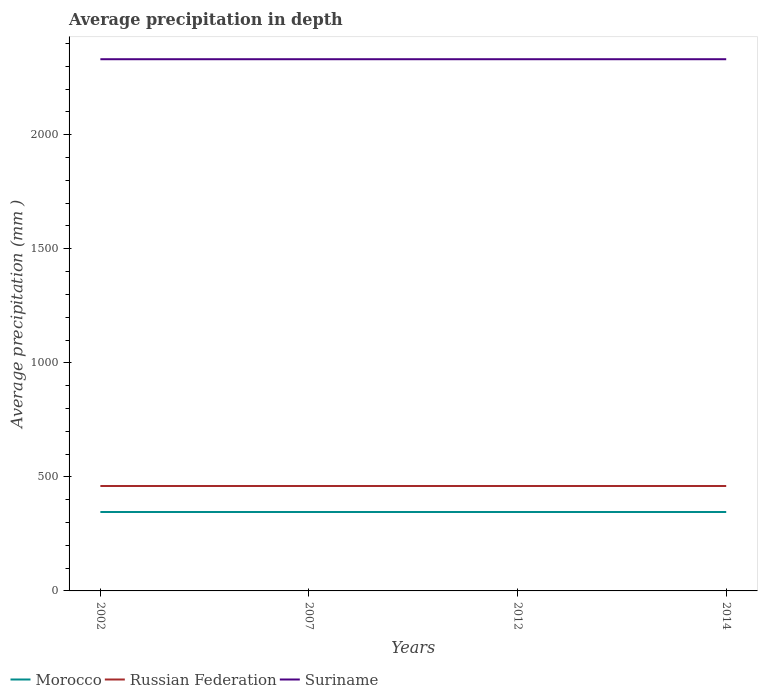How many different coloured lines are there?
Ensure brevity in your answer.  3. Across all years, what is the maximum average precipitation in Russian Federation?
Your response must be concise. 460. In which year was the average precipitation in Russian Federation maximum?
Your response must be concise. 2002. What is the total average precipitation in Russian Federation in the graph?
Make the answer very short. 0. What is the difference between the highest and the lowest average precipitation in Morocco?
Provide a short and direct response. 0. How many years are there in the graph?
Your answer should be compact. 4. Does the graph contain any zero values?
Provide a succinct answer. No. Where does the legend appear in the graph?
Provide a short and direct response. Bottom left. How many legend labels are there?
Your response must be concise. 3. What is the title of the graph?
Your answer should be compact. Average precipitation in depth. What is the label or title of the Y-axis?
Keep it short and to the point. Average precipitation (mm ). What is the Average precipitation (mm ) in Morocco in 2002?
Offer a very short reply. 346. What is the Average precipitation (mm ) of Russian Federation in 2002?
Give a very brief answer. 460. What is the Average precipitation (mm ) in Suriname in 2002?
Provide a succinct answer. 2331. What is the Average precipitation (mm ) in Morocco in 2007?
Keep it short and to the point. 346. What is the Average precipitation (mm ) in Russian Federation in 2007?
Your answer should be very brief. 460. What is the Average precipitation (mm ) in Suriname in 2007?
Make the answer very short. 2331. What is the Average precipitation (mm ) of Morocco in 2012?
Offer a terse response. 346. What is the Average precipitation (mm ) in Russian Federation in 2012?
Your answer should be very brief. 460. What is the Average precipitation (mm ) in Suriname in 2012?
Provide a succinct answer. 2331. What is the Average precipitation (mm ) of Morocco in 2014?
Make the answer very short. 346. What is the Average precipitation (mm ) in Russian Federation in 2014?
Offer a terse response. 460. What is the Average precipitation (mm ) in Suriname in 2014?
Offer a very short reply. 2331. Across all years, what is the maximum Average precipitation (mm ) of Morocco?
Ensure brevity in your answer.  346. Across all years, what is the maximum Average precipitation (mm ) of Russian Federation?
Ensure brevity in your answer.  460. Across all years, what is the maximum Average precipitation (mm ) of Suriname?
Ensure brevity in your answer.  2331. Across all years, what is the minimum Average precipitation (mm ) in Morocco?
Offer a very short reply. 346. Across all years, what is the minimum Average precipitation (mm ) of Russian Federation?
Your response must be concise. 460. Across all years, what is the minimum Average precipitation (mm ) in Suriname?
Make the answer very short. 2331. What is the total Average precipitation (mm ) of Morocco in the graph?
Provide a short and direct response. 1384. What is the total Average precipitation (mm ) of Russian Federation in the graph?
Your response must be concise. 1840. What is the total Average precipitation (mm ) of Suriname in the graph?
Your answer should be compact. 9324. What is the difference between the Average precipitation (mm ) in Morocco in 2002 and that in 2007?
Provide a short and direct response. 0. What is the difference between the Average precipitation (mm ) of Morocco in 2002 and that in 2012?
Your answer should be very brief. 0. What is the difference between the Average precipitation (mm ) of Suriname in 2002 and that in 2012?
Offer a very short reply. 0. What is the difference between the Average precipitation (mm ) of Suriname in 2002 and that in 2014?
Your response must be concise. 0. What is the difference between the Average precipitation (mm ) of Morocco in 2007 and that in 2012?
Your response must be concise. 0. What is the difference between the Average precipitation (mm ) of Morocco in 2007 and that in 2014?
Your answer should be compact. 0. What is the difference between the Average precipitation (mm ) of Suriname in 2012 and that in 2014?
Your answer should be very brief. 0. What is the difference between the Average precipitation (mm ) in Morocco in 2002 and the Average precipitation (mm ) in Russian Federation in 2007?
Provide a succinct answer. -114. What is the difference between the Average precipitation (mm ) of Morocco in 2002 and the Average precipitation (mm ) of Suriname in 2007?
Your answer should be very brief. -1985. What is the difference between the Average precipitation (mm ) of Russian Federation in 2002 and the Average precipitation (mm ) of Suriname in 2007?
Give a very brief answer. -1871. What is the difference between the Average precipitation (mm ) in Morocco in 2002 and the Average precipitation (mm ) in Russian Federation in 2012?
Provide a succinct answer. -114. What is the difference between the Average precipitation (mm ) of Morocco in 2002 and the Average precipitation (mm ) of Suriname in 2012?
Your answer should be very brief. -1985. What is the difference between the Average precipitation (mm ) in Russian Federation in 2002 and the Average precipitation (mm ) in Suriname in 2012?
Give a very brief answer. -1871. What is the difference between the Average precipitation (mm ) in Morocco in 2002 and the Average precipitation (mm ) in Russian Federation in 2014?
Your answer should be compact. -114. What is the difference between the Average precipitation (mm ) in Morocco in 2002 and the Average precipitation (mm ) in Suriname in 2014?
Your response must be concise. -1985. What is the difference between the Average precipitation (mm ) of Russian Federation in 2002 and the Average precipitation (mm ) of Suriname in 2014?
Provide a short and direct response. -1871. What is the difference between the Average precipitation (mm ) of Morocco in 2007 and the Average precipitation (mm ) of Russian Federation in 2012?
Make the answer very short. -114. What is the difference between the Average precipitation (mm ) in Morocco in 2007 and the Average precipitation (mm ) in Suriname in 2012?
Make the answer very short. -1985. What is the difference between the Average precipitation (mm ) of Russian Federation in 2007 and the Average precipitation (mm ) of Suriname in 2012?
Give a very brief answer. -1871. What is the difference between the Average precipitation (mm ) in Morocco in 2007 and the Average precipitation (mm ) in Russian Federation in 2014?
Offer a terse response. -114. What is the difference between the Average precipitation (mm ) of Morocco in 2007 and the Average precipitation (mm ) of Suriname in 2014?
Make the answer very short. -1985. What is the difference between the Average precipitation (mm ) of Russian Federation in 2007 and the Average precipitation (mm ) of Suriname in 2014?
Your answer should be compact. -1871. What is the difference between the Average precipitation (mm ) in Morocco in 2012 and the Average precipitation (mm ) in Russian Federation in 2014?
Provide a short and direct response. -114. What is the difference between the Average precipitation (mm ) in Morocco in 2012 and the Average precipitation (mm ) in Suriname in 2014?
Make the answer very short. -1985. What is the difference between the Average precipitation (mm ) in Russian Federation in 2012 and the Average precipitation (mm ) in Suriname in 2014?
Your response must be concise. -1871. What is the average Average precipitation (mm ) in Morocco per year?
Offer a terse response. 346. What is the average Average precipitation (mm ) of Russian Federation per year?
Give a very brief answer. 460. What is the average Average precipitation (mm ) in Suriname per year?
Provide a succinct answer. 2331. In the year 2002, what is the difference between the Average precipitation (mm ) of Morocco and Average precipitation (mm ) of Russian Federation?
Your answer should be very brief. -114. In the year 2002, what is the difference between the Average precipitation (mm ) of Morocco and Average precipitation (mm ) of Suriname?
Make the answer very short. -1985. In the year 2002, what is the difference between the Average precipitation (mm ) in Russian Federation and Average precipitation (mm ) in Suriname?
Your answer should be very brief. -1871. In the year 2007, what is the difference between the Average precipitation (mm ) of Morocco and Average precipitation (mm ) of Russian Federation?
Give a very brief answer. -114. In the year 2007, what is the difference between the Average precipitation (mm ) of Morocco and Average precipitation (mm ) of Suriname?
Provide a short and direct response. -1985. In the year 2007, what is the difference between the Average precipitation (mm ) in Russian Federation and Average precipitation (mm ) in Suriname?
Make the answer very short. -1871. In the year 2012, what is the difference between the Average precipitation (mm ) of Morocco and Average precipitation (mm ) of Russian Federation?
Provide a short and direct response. -114. In the year 2012, what is the difference between the Average precipitation (mm ) in Morocco and Average precipitation (mm ) in Suriname?
Provide a short and direct response. -1985. In the year 2012, what is the difference between the Average precipitation (mm ) in Russian Federation and Average precipitation (mm ) in Suriname?
Your answer should be very brief. -1871. In the year 2014, what is the difference between the Average precipitation (mm ) in Morocco and Average precipitation (mm ) in Russian Federation?
Provide a short and direct response. -114. In the year 2014, what is the difference between the Average precipitation (mm ) of Morocco and Average precipitation (mm ) of Suriname?
Make the answer very short. -1985. In the year 2014, what is the difference between the Average precipitation (mm ) of Russian Federation and Average precipitation (mm ) of Suriname?
Make the answer very short. -1871. What is the ratio of the Average precipitation (mm ) of Suriname in 2002 to that in 2007?
Offer a terse response. 1. What is the ratio of the Average precipitation (mm ) of Russian Federation in 2002 to that in 2012?
Your answer should be very brief. 1. What is the ratio of the Average precipitation (mm ) in Morocco in 2002 to that in 2014?
Ensure brevity in your answer.  1. What is the ratio of the Average precipitation (mm ) of Suriname in 2002 to that in 2014?
Keep it short and to the point. 1. What is the ratio of the Average precipitation (mm ) of Russian Federation in 2007 to that in 2012?
Give a very brief answer. 1. What is the ratio of the Average precipitation (mm ) of Morocco in 2007 to that in 2014?
Your answer should be compact. 1. What is the ratio of the Average precipitation (mm ) in Russian Federation in 2012 to that in 2014?
Keep it short and to the point. 1. What is the difference between the highest and the second highest Average precipitation (mm ) in Russian Federation?
Ensure brevity in your answer.  0. What is the difference between the highest and the lowest Average precipitation (mm ) of Morocco?
Give a very brief answer. 0. What is the difference between the highest and the lowest Average precipitation (mm ) in Suriname?
Give a very brief answer. 0. 